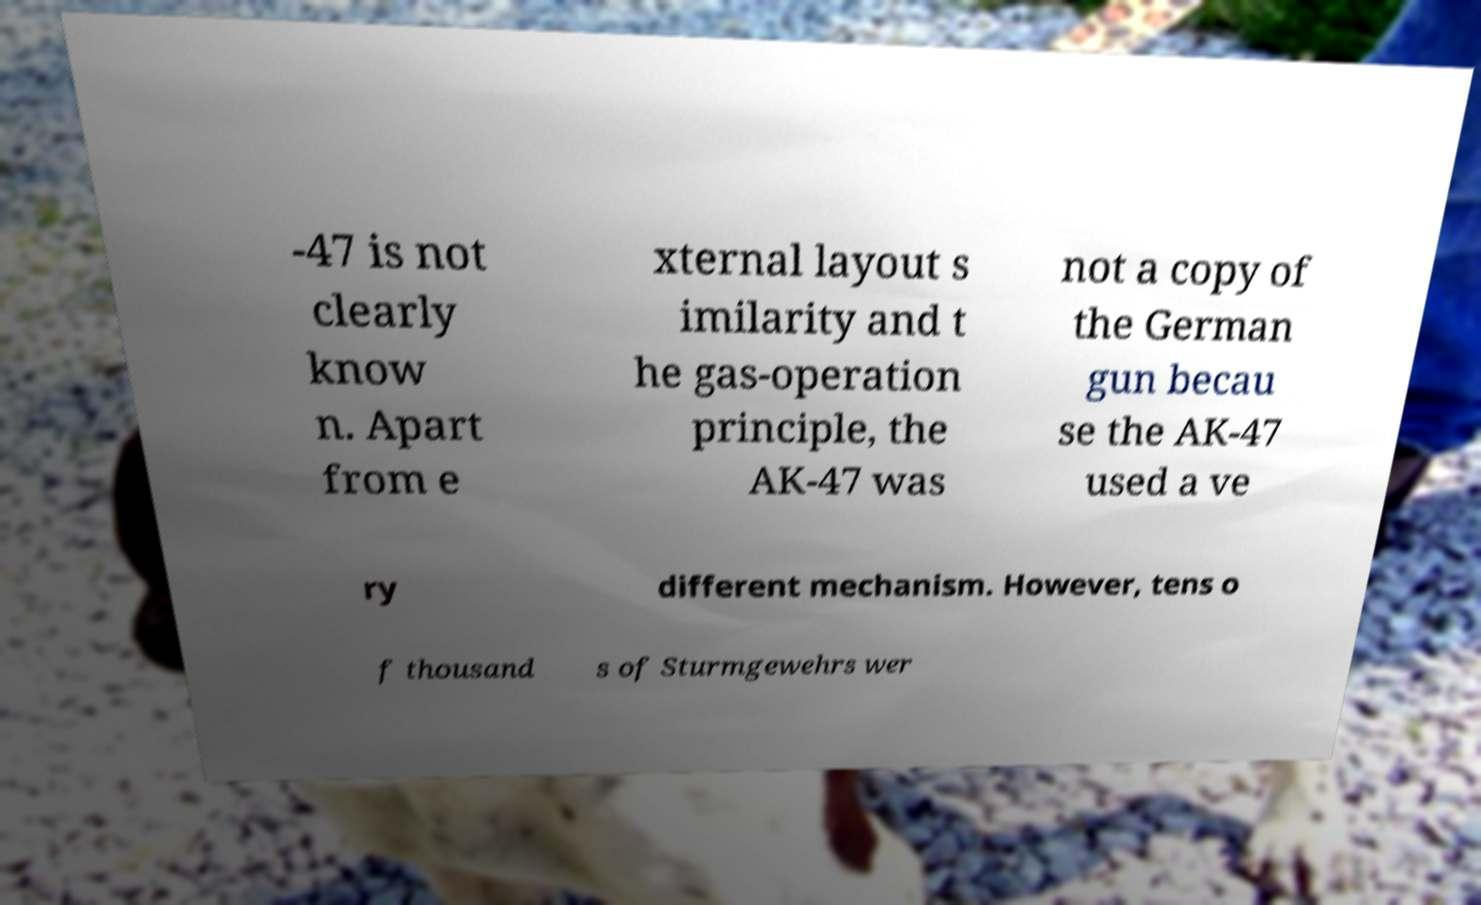Could you assist in decoding the text presented in this image and type it out clearly? -47 is not clearly know n. Apart from e xternal layout s imilarity and t he gas-operation principle, the AK-47 was not a copy of the German gun becau se the AK-47 used a ve ry different mechanism. However, tens o f thousand s of Sturmgewehrs wer 